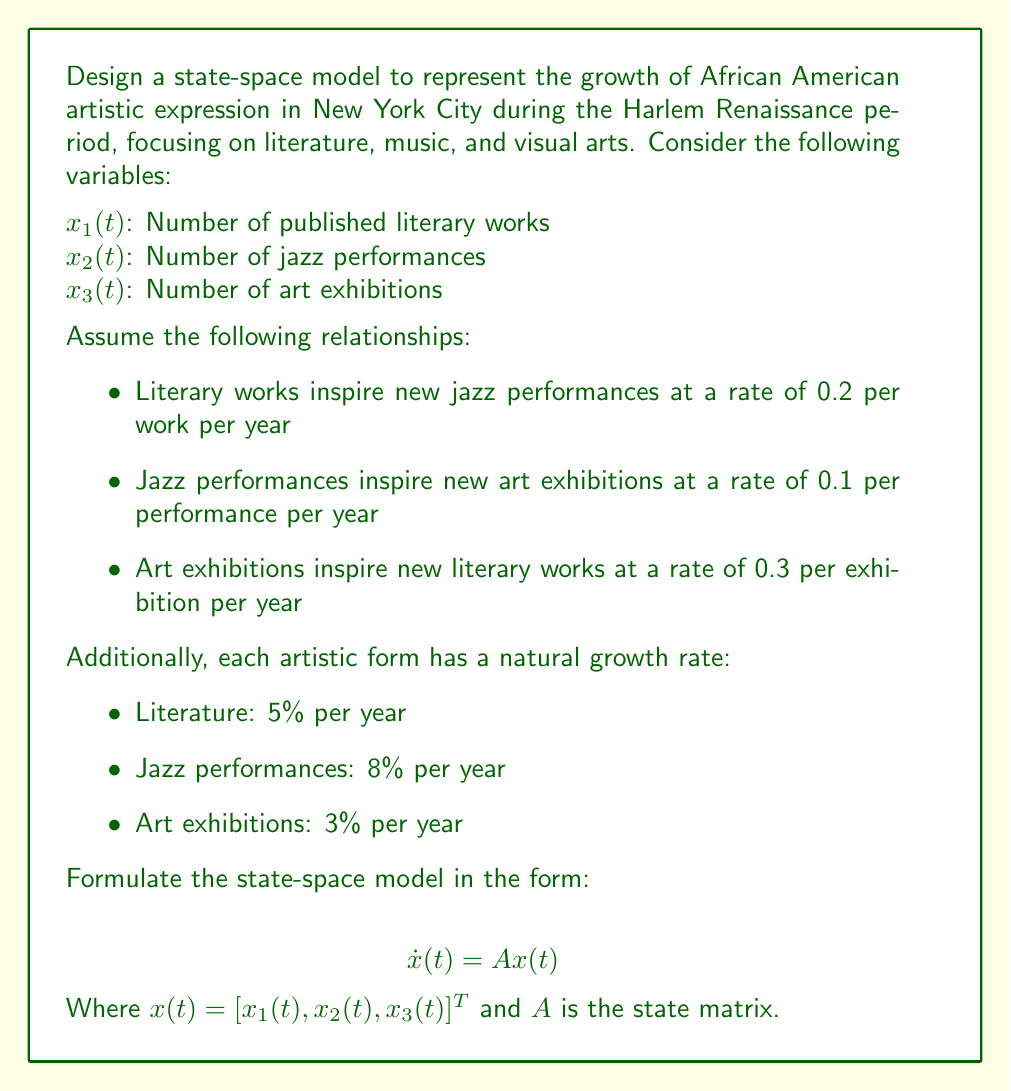Solve this math problem. To formulate the state-space model, we need to create a system of differential equations that represent the relationships between the variables and their growth rates. Let's break it down step by step:

1. For $x_1(t)$ (literary works):
   - Natural growth: $0.05x_1(t)$
   - Inspired by art exhibitions: $0.3x_3(t)$
   
   $$\dot{x_1}(t) = 0.05x_1(t) + 0.3x_3(t)$$

2. For $x_2(t)$ (jazz performances):
   - Natural growth: $0.08x_2(t)$
   - Inspired by literary works: $0.2x_1(t)$
   
   $$\dot{x_2}(t) = 0.2x_1(t) + 0.08x_2(t)$$

3. For $x_3(t)$ (art exhibitions):
   - Natural growth: $0.03x_3(t)$
   - Inspired by jazz performances: $0.1x_2(t)$
   
   $$\dot{x_3}(t) = 0.1x_2(t) + 0.03x_3(t)$$

Now, we can represent this system in matrix form:

$$
\begin{bmatrix}
\dot{x_1}(t) \\
\dot{x_2}(t) \\
\dot{x_3}(t)
\end{bmatrix}
=
\begin{bmatrix}
0.05 & 0 & 0.3 \\
0.2 & 0.08 & 0 \\
0 & 0.1 & 0.03
\end{bmatrix}
\begin{bmatrix}
x_1(t) \\
x_2(t) \\
x_3(t)
\end{bmatrix}
$$

This can be written in the standard state-space form:

$$\dot{x}(t) = Ax(t)$$

Where $x(t) = [x_1(t), x_2(t), x_3(t)]^T$ and $A$ is the state matrix.
Answer: The state-space model is:

$$\dot{x}(t) = Ax(t)$$

Where:

$$A = 
\begin{bmatrix}
0.05 & 0 & 0.3 \\
0.2 & 0.08 & 0 \\
0 & 0.1 & 0.03
\end{bmatrix}$$

and $x(t) = [x_1(t), x_2(t), x_3(t)]^T$ 